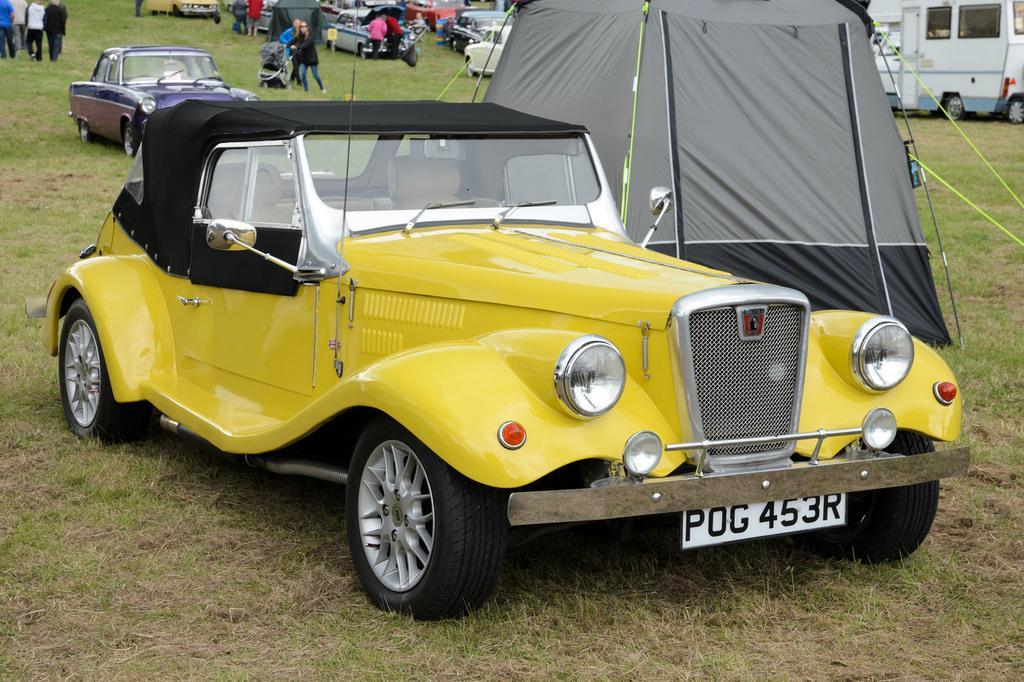Describe this image in one or two sentences. In this image there are cars and tents on a land, in the background there are people. 